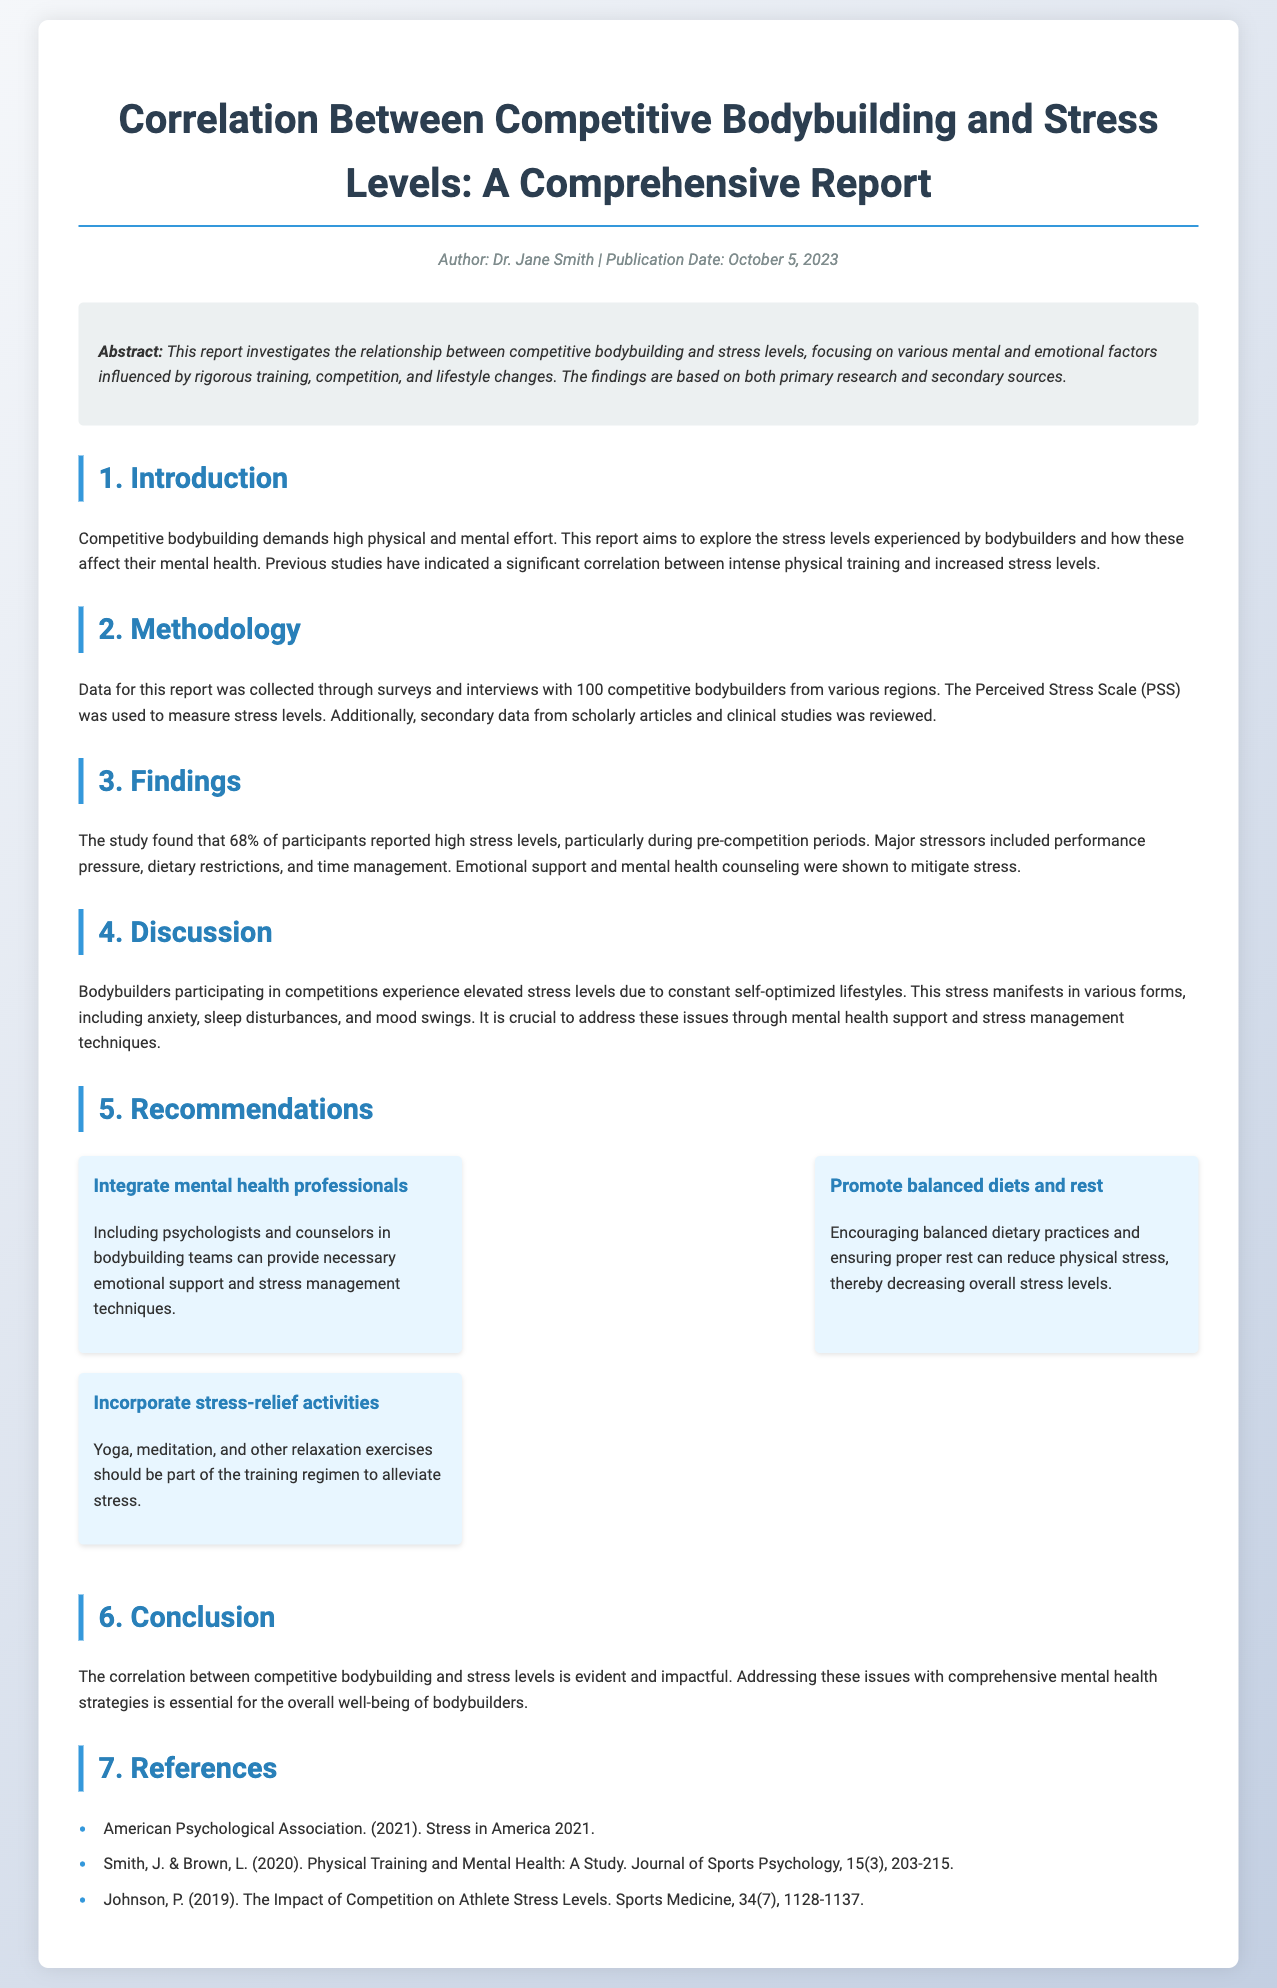What percentage of participants reported high stress levels? 68% of participants reported high stress levels, particularly during pre-competition periods.
Answer: 68% What is the main tool used to measure stress levels? The Perceived Stress Scale (PSS) was used to measure stress levels among participants.
Answer: Perceived Stress Scale (PSS) Who authored the report? The report was authored by Dr. Jane Smith, as indicated in the meta-info section.
Answer: Dr. Jane Smith What are some major stressors identified in the study? Performance pressure, dietary restrictions, and time management were identified as major stressors in the study.
Answer: Performance pressure, dietary restrictions, time management What is one recommendation for reducing stress in bodybuilders? One recommendation is to incorporate stress-relief activities like yoga and meditation into their training regimen.
Answer: Incorporate stress-relief activities During which period do bodybuilders experience increased stress levels? Bodybuilders reported increased stress levels particularly during the pre-competition periods.
Answer: Pre-competition periods What type of document is this report classified as? This report presents findings from a study and is classified as a comprehensive report on a specific research topic.
Answer: Comprehensive report How many bodybuilders were surveyed for the study? A total of 100 competitive bodybuilders were surveyed for this study.
Answer: 100 